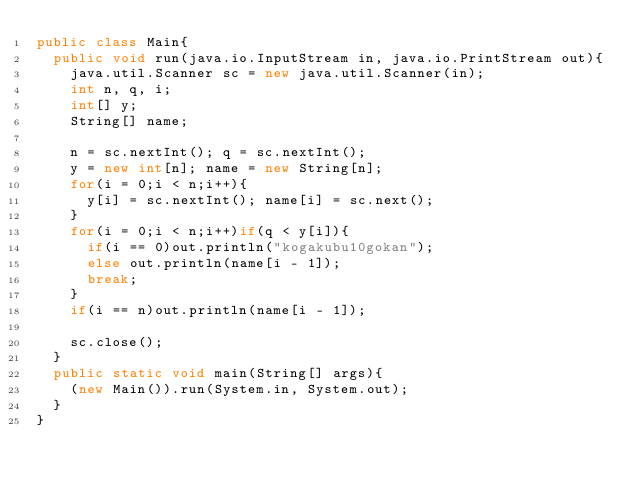Convert code to text. <code><loc_0><loc_0><loc_500><loc_500><_Java_>public class Main{
  public void run(java.io.InputStream in, java.io.PrintStream out){
    java.util.Scanner sc = new java.util.Scanner(in);
    int n, q, i;
    int[] y;
    String[] name;

    n = sc.nextInt(); q = sc.nextInt();
    y = new int[n]; name = new String[n];
    for(i = 0;i < n;i++){
      y[i] = sc.nextInt(); name[i] = sc.next();
    }
    for(i = 0;i < n;i++)if(q < y[i]){
      if(i == 0)out.println("kogakubu10gokan");
      else out.println(name[i - 1]);
      break;
    }
    if(i == n)out.println(name[i - 1]);

    sc.close();
  }
  public static void main(String[] args){
    (new Main()).run(System.in, System.out);
  }
}</code> 